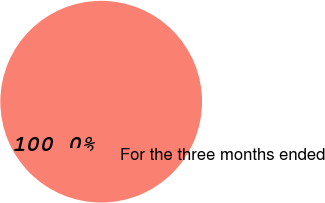Convert chart to OTSL. <chart><loc_0><loc_0><loc_500><loc_500><pie_chart><fcel>For the three months ended<nl><fcel>100.0%<nl></chart> 